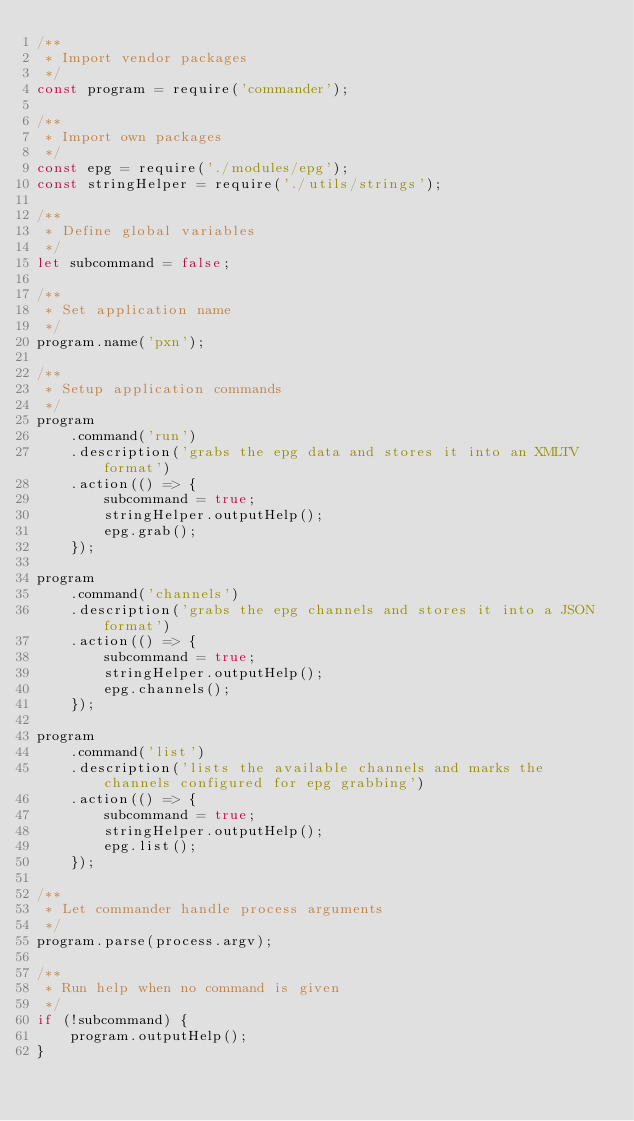Convert code to text. <code><loc_0><loc_0><loc_500><loc_500><_JavaScript_>/**
 * Import vendor packages
 */
const program = require('commander');

/**
 * Import own packages
 */
const epg = require('./modules/epg');
const stringHelper = require('./utils/strings');

/**
 * Define global variables
 */
let subcommand = false;

/**
 * Set application name
 */
program.name('pxn');

/**
 * Setup application commands
 */
program
    .command('run')
    .description('grabs the epg data and stores it into an XMLTV format')
    .action(() => {
        subcommand = true;
        stringHelper.outputHelp();
        epg.grab();
    });

program
    .command('channels')
    .description('grabs the epg channels and stores it into a JSON format')
    .action(() => {
        subcommand = true;
        stringHelper.outputHelp();
        epg.channels();
    });

program
    .command('list')
    .description('lists the available channels and marks the channels configured for epg grabbing')
    .action(() => {
        subcommand = true;
        stringHelper.outputHelp();
        epg.list();
    });

/**
 * Let commander handle process arguments
 */
program.parse(process.argv);

/**
 * Run help when no command is given
 */
if (!subcommand) {
    program.outputHelp();
}
</code> 